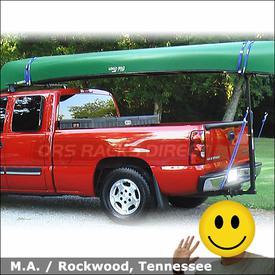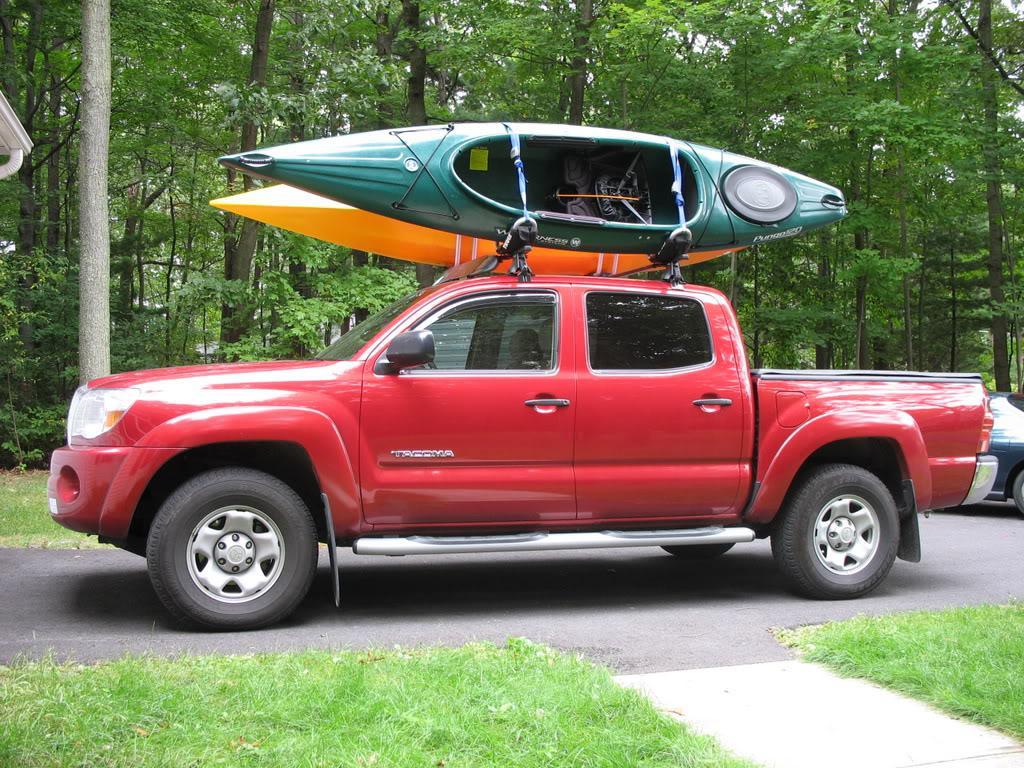The first image is the image on the left, the second image is the image on the right. For the images shown, is this caption "A body of water is visible behind a truck" true? Answer yes or no. No. 